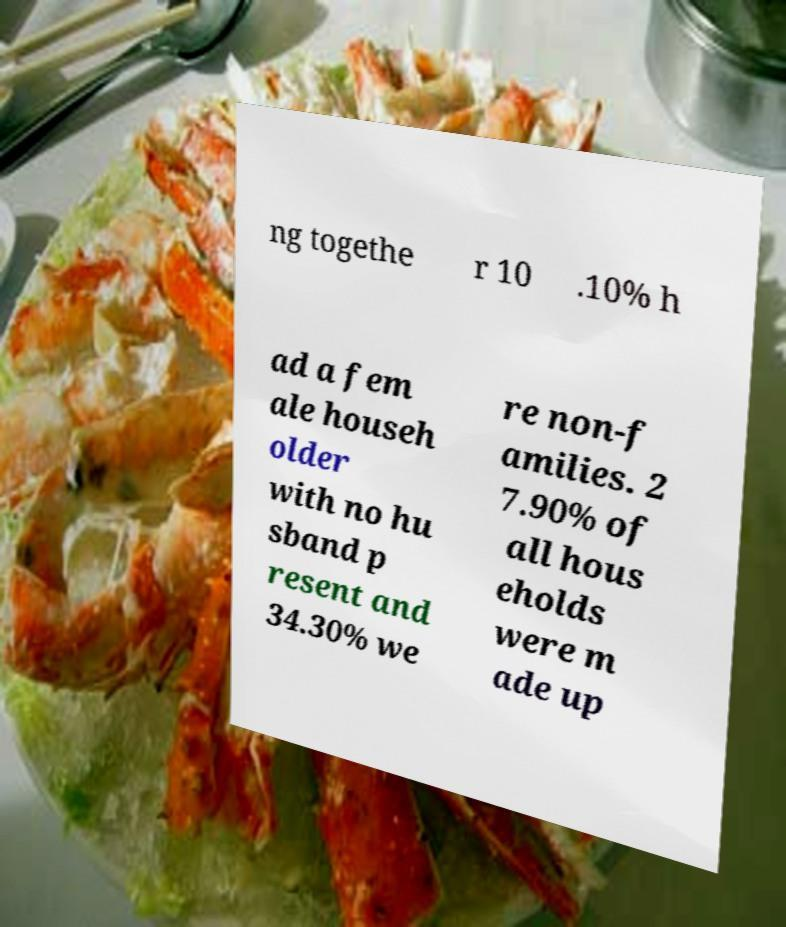Can you read and provide the text displayed in the image?This photo seems to have some interesting text. Can you extract and type it out for me? ng togethe r 10 .10% h ad a fem ale househ older with no hu sband p resent and 34.30% we re non-f amilies. 2 7.90% of all hous eholds were m ade up 